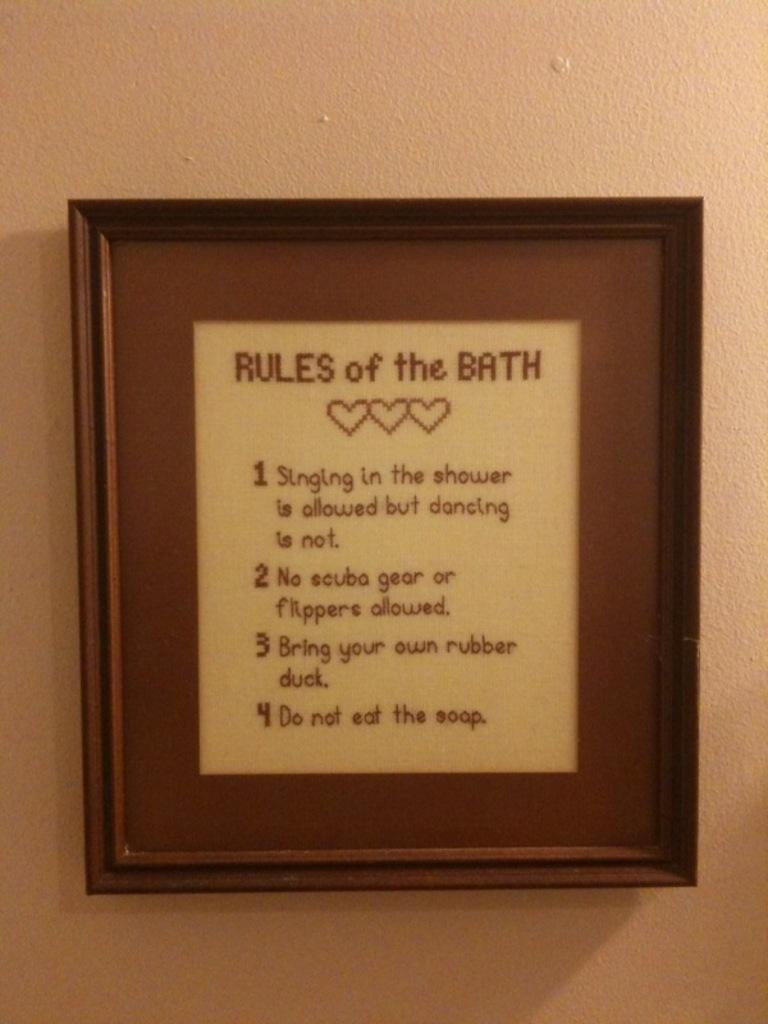<image>
Summarize the visual content of the image. a print of "rules of the bath", including "Do not eat the soap" 